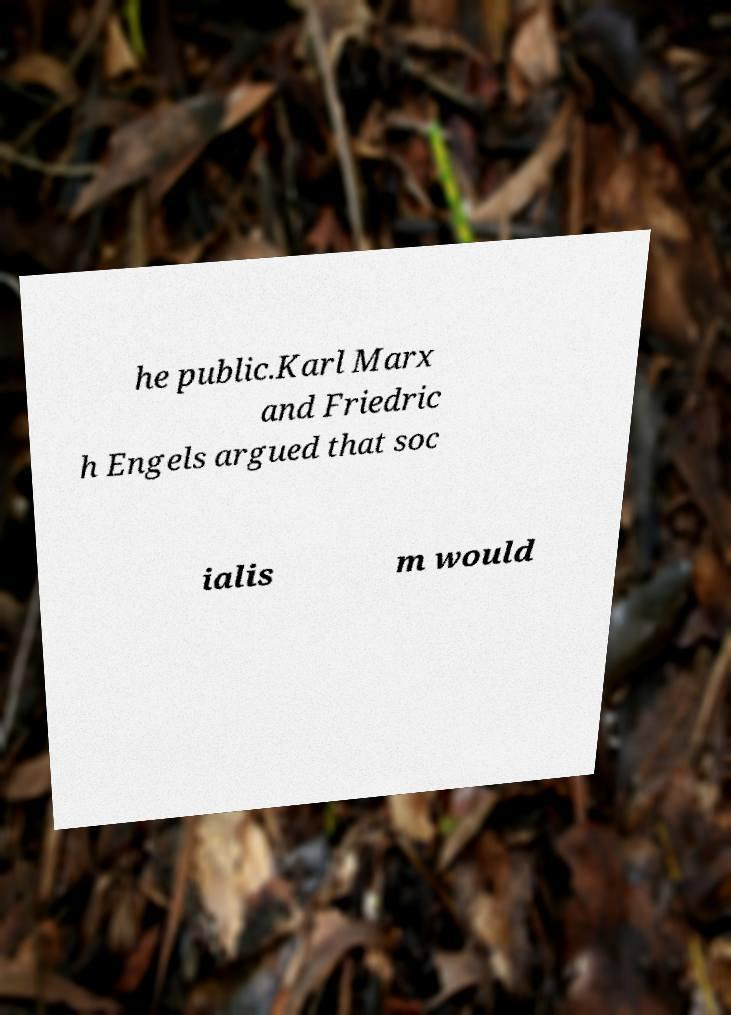Please read and relay the text visible in this image. What does it say? he public.Karl Marx and Friedric h Engels argued that soc ialis m would 